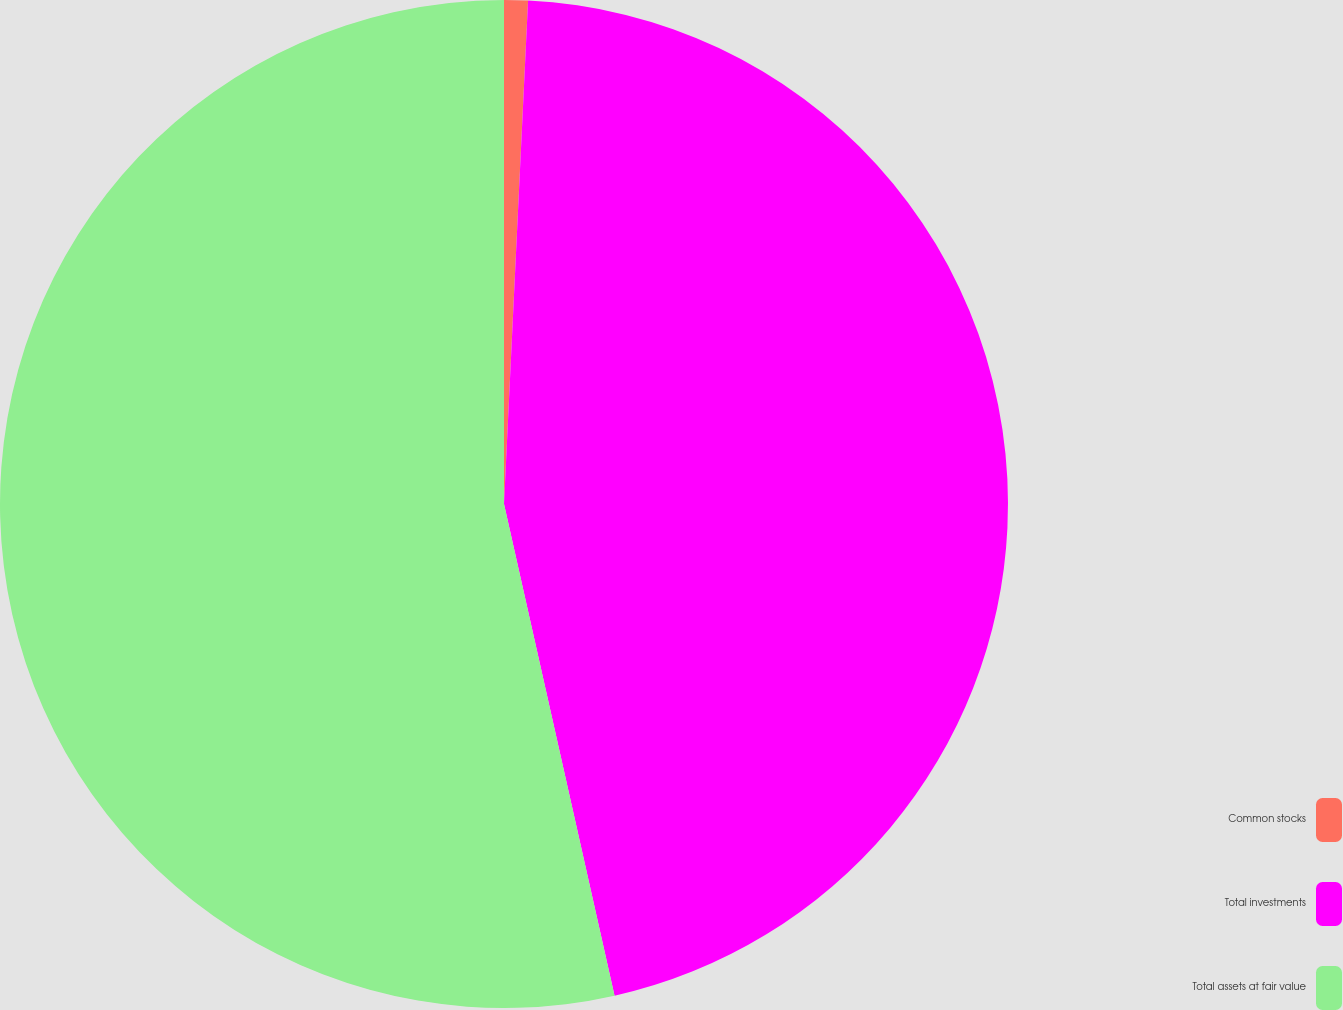Convert chart. <chart><loc_0><loc_0><loc_500><loc_500><pie_chart><fcel>Common stocks<fcel>Total investments<fcel>Total assets at fair value<nl><fcel>0.76%<fcel>45.72%<fcel>53.52%<nl></chart> 